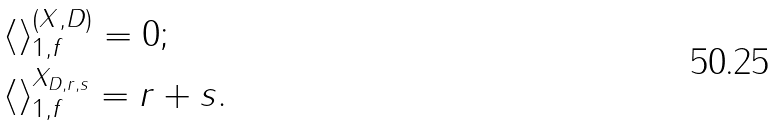<formula> <loc_0><loc_0><loc_500><loc_500>& \langle \rangle _ { 1 , f } ^ { ( X , D ) } = 0 ; \\ & \langle \rangle _ { 1 , f } ^ { X _ { D , r , s } } = r + s .</formula> 